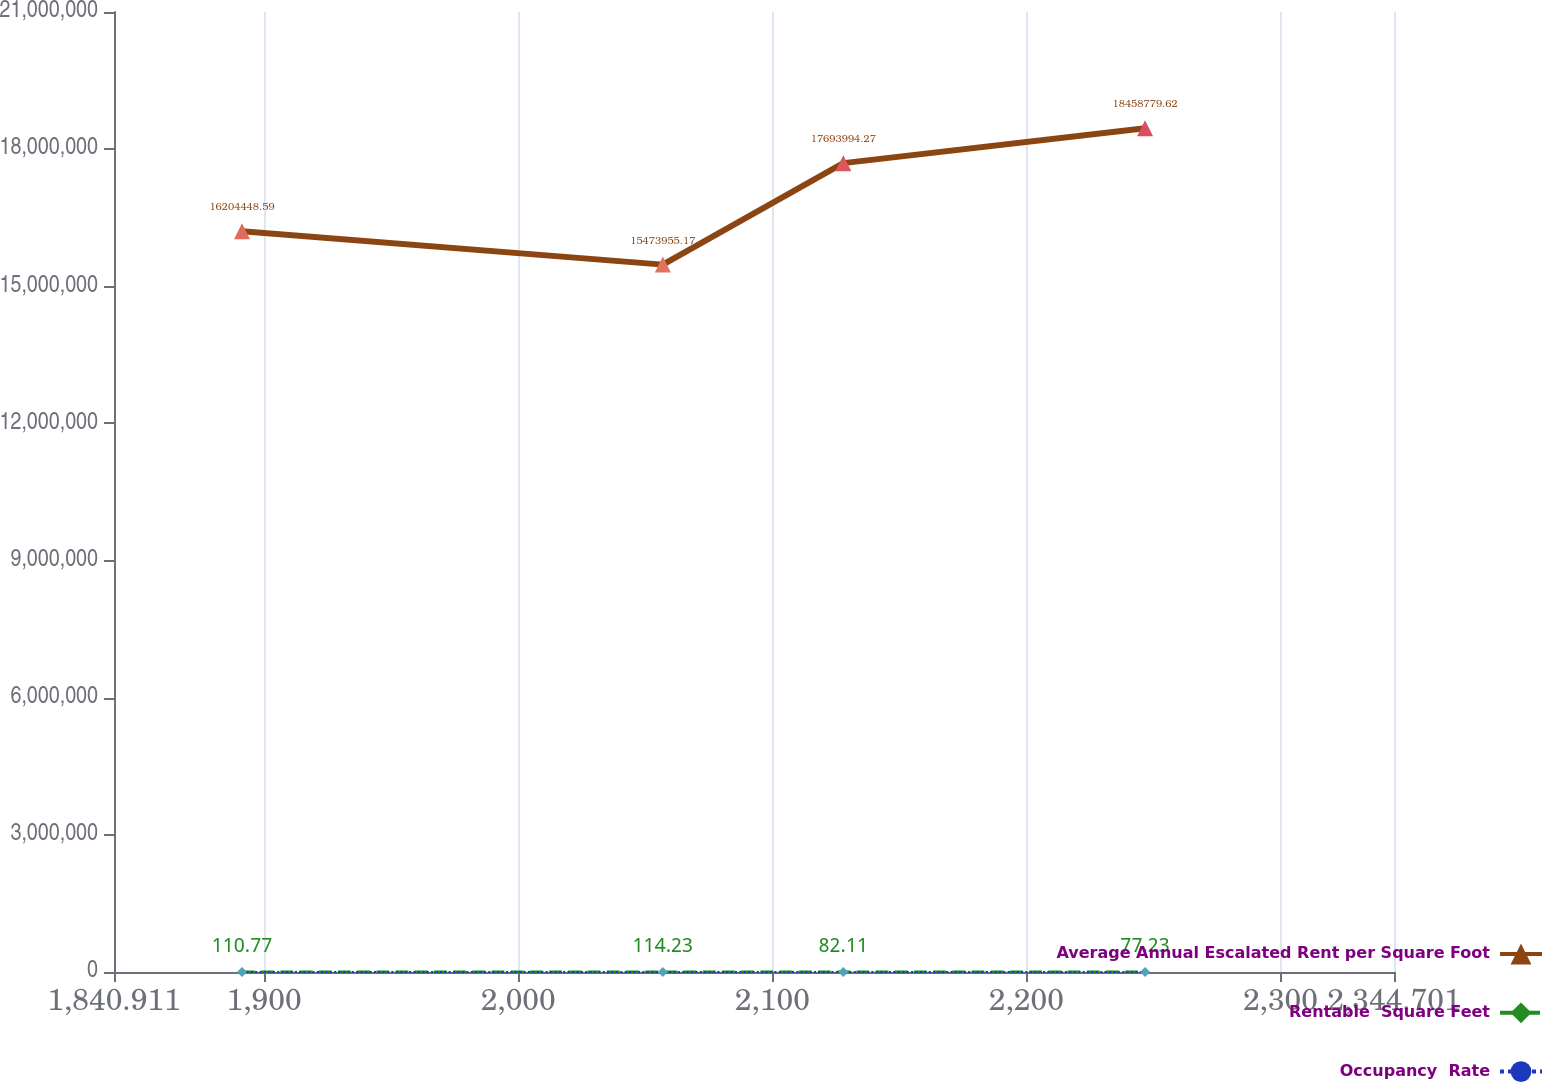Convert chart. <chart><loc_0><loc_0><loc_500><loc_500><line_chart><ecel><fcel>Average Annual Escalated Rent per Square Foot<fcel>Rentable  Square Feet<fcel>Occupancy  Rate<nl><fcel>1891.29<fcel>1.62044e+07<fcel>110.77<fcel>31.73<nl><fcel>2056.92<fcel>1.5474e+07<fcel>114.23<fcel>41.01<nl><fcel>2127.95<fcel>1.7694e+07<fcel>82.11<fcel>37.98<nl><fcel>2246.73<fcel>1.84588e+07<fcel>77.23<fcel>36.87<nl><fcel>2395.08<fcel>1.34088e+07<fcel>101.48<fcel>33.68<nl></chart> 